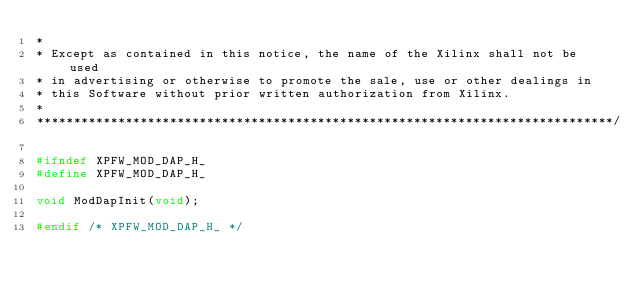Convert code to text. <code><loc_0><loc_0><loc_500><loc_500><_C_>*
* Except as contained in this notice, the name of the Xilinx shall not be used
* in advertising or otherwise to promote the sale, use or other dealings in
* this Software without prior written authorization from Xilinx.
*
******************************************************************************/

#ifndef XPFW_MOD_DAP_H_
#define XPFW_MOD_DAP_H_

void ModDapInit(void);

#endif /* XPFW_MOD_DAP_H_ */
</code> 